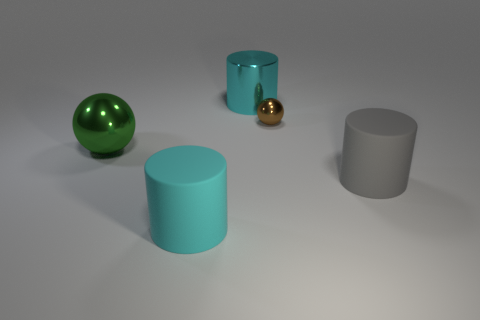Does the large metallic thing behind the brown sphere have the same shape as the large thing right of the large cyan metallic cylinder? yes 